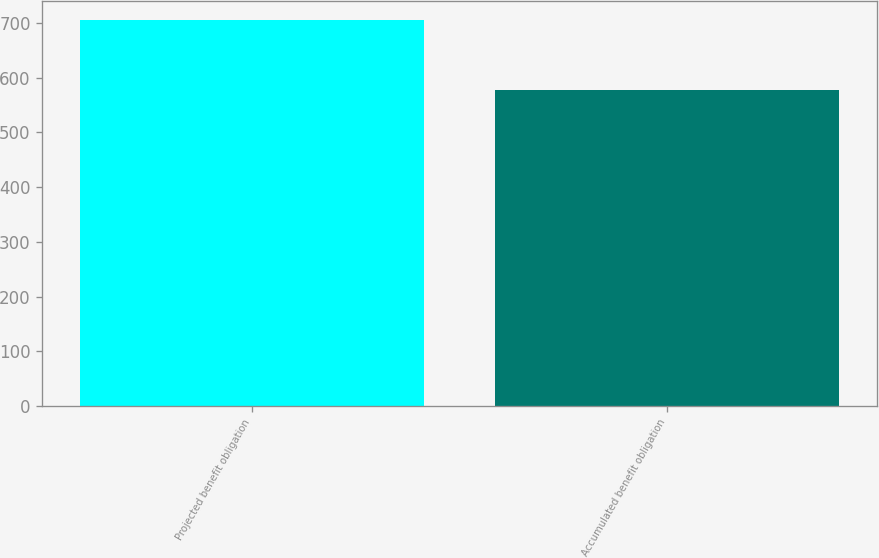Convert chart to OTSL. <chart><loc_0><loc_0><loc_500><loc_500><bar_chart><fcel>Projected benefit obligation<fcel>Accumulated benefit obligation<nl><fcel>705<fcel>578<nl></chart> 